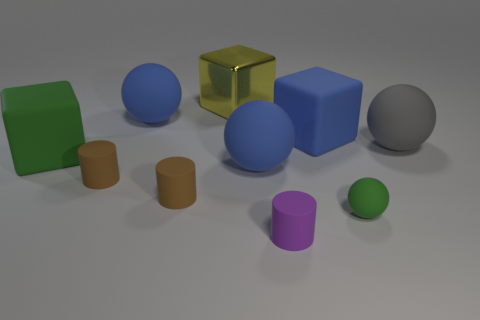How many big cubes are the same color as the tiny ball?
Keep it short and to the point. 1. What is the size of the block that is the same color as the small sphere?
Make the answer very short. Large. How many other objects are the same shape as the big yellow metal thing?
Keep it short and to the point. 2. There is a gray ball; is its size the same as the ball behind the big gray matte sphere?
Your answer should be very brief. Yes. What number of objects are either purple matte objects or cyan matte cylinders?
Make the answer very short. 1. How many other things are there of the same size as the gray matte object?
Give a very brief answer. 5. Does the shiny cube have the same color as the rubber sphere to the right of the tiny green ball?
Your response must be concise. No. What number of spheres are tiny cyan things or big gray matte objects?
Provide a succinct answer. 1. Is there anything else that has the same color as the tiny sphere?
Offer a very short reply. Yes. There is a large block that is on the right side of the small rubber cylinder that is to the right of the yellow metal object; what is it made of?
Give a very brief answer. Rubber. 